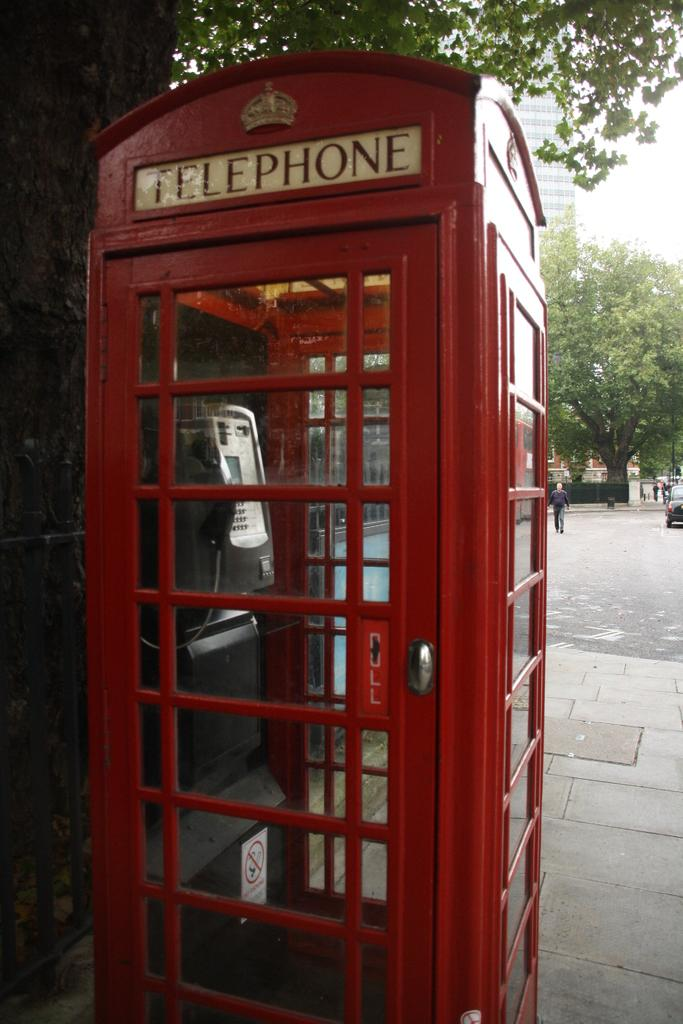<image>
Provide a brief description of the given image. A red booth with a phone inside says Telephone on the top. 